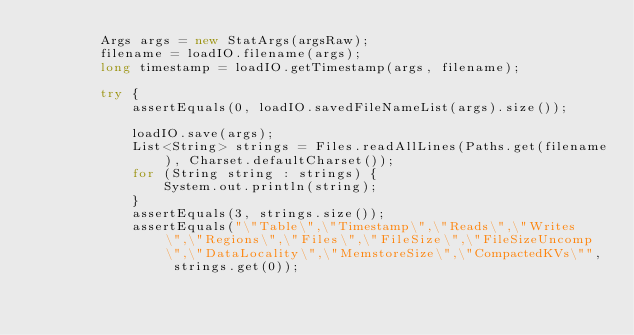Convert code to text. <code><loc_0><loc_0><loc_500><loc_500><_Java_>        Args args = new StatArgs(argsRaw);
        filename = loadIO.filename(args);
        long timestamp = loadIO.getTimestamp(args, filename);

        try {
            assertEquals(0, loadIO.savedFileNameList(args).size());

            loadIO.save(args);
            List<String> strings = Files.readAllLines(Paths.get(filename), Charset.defaultCharset());
            for (String string : strings) {
                System.out.println(string);
            }
            assertEquals(3, strings.size());
            assertEquals("\"Table\",\"Timestamp\",\"Reads\",\"Writes\",\"Regions\",\"Files\",\"FileSize\",\"FileSizeUncomp\",\"DataLocality\",\"MemstoreSize\",\"CompactedKVs\"", strings.get(0));</code> 